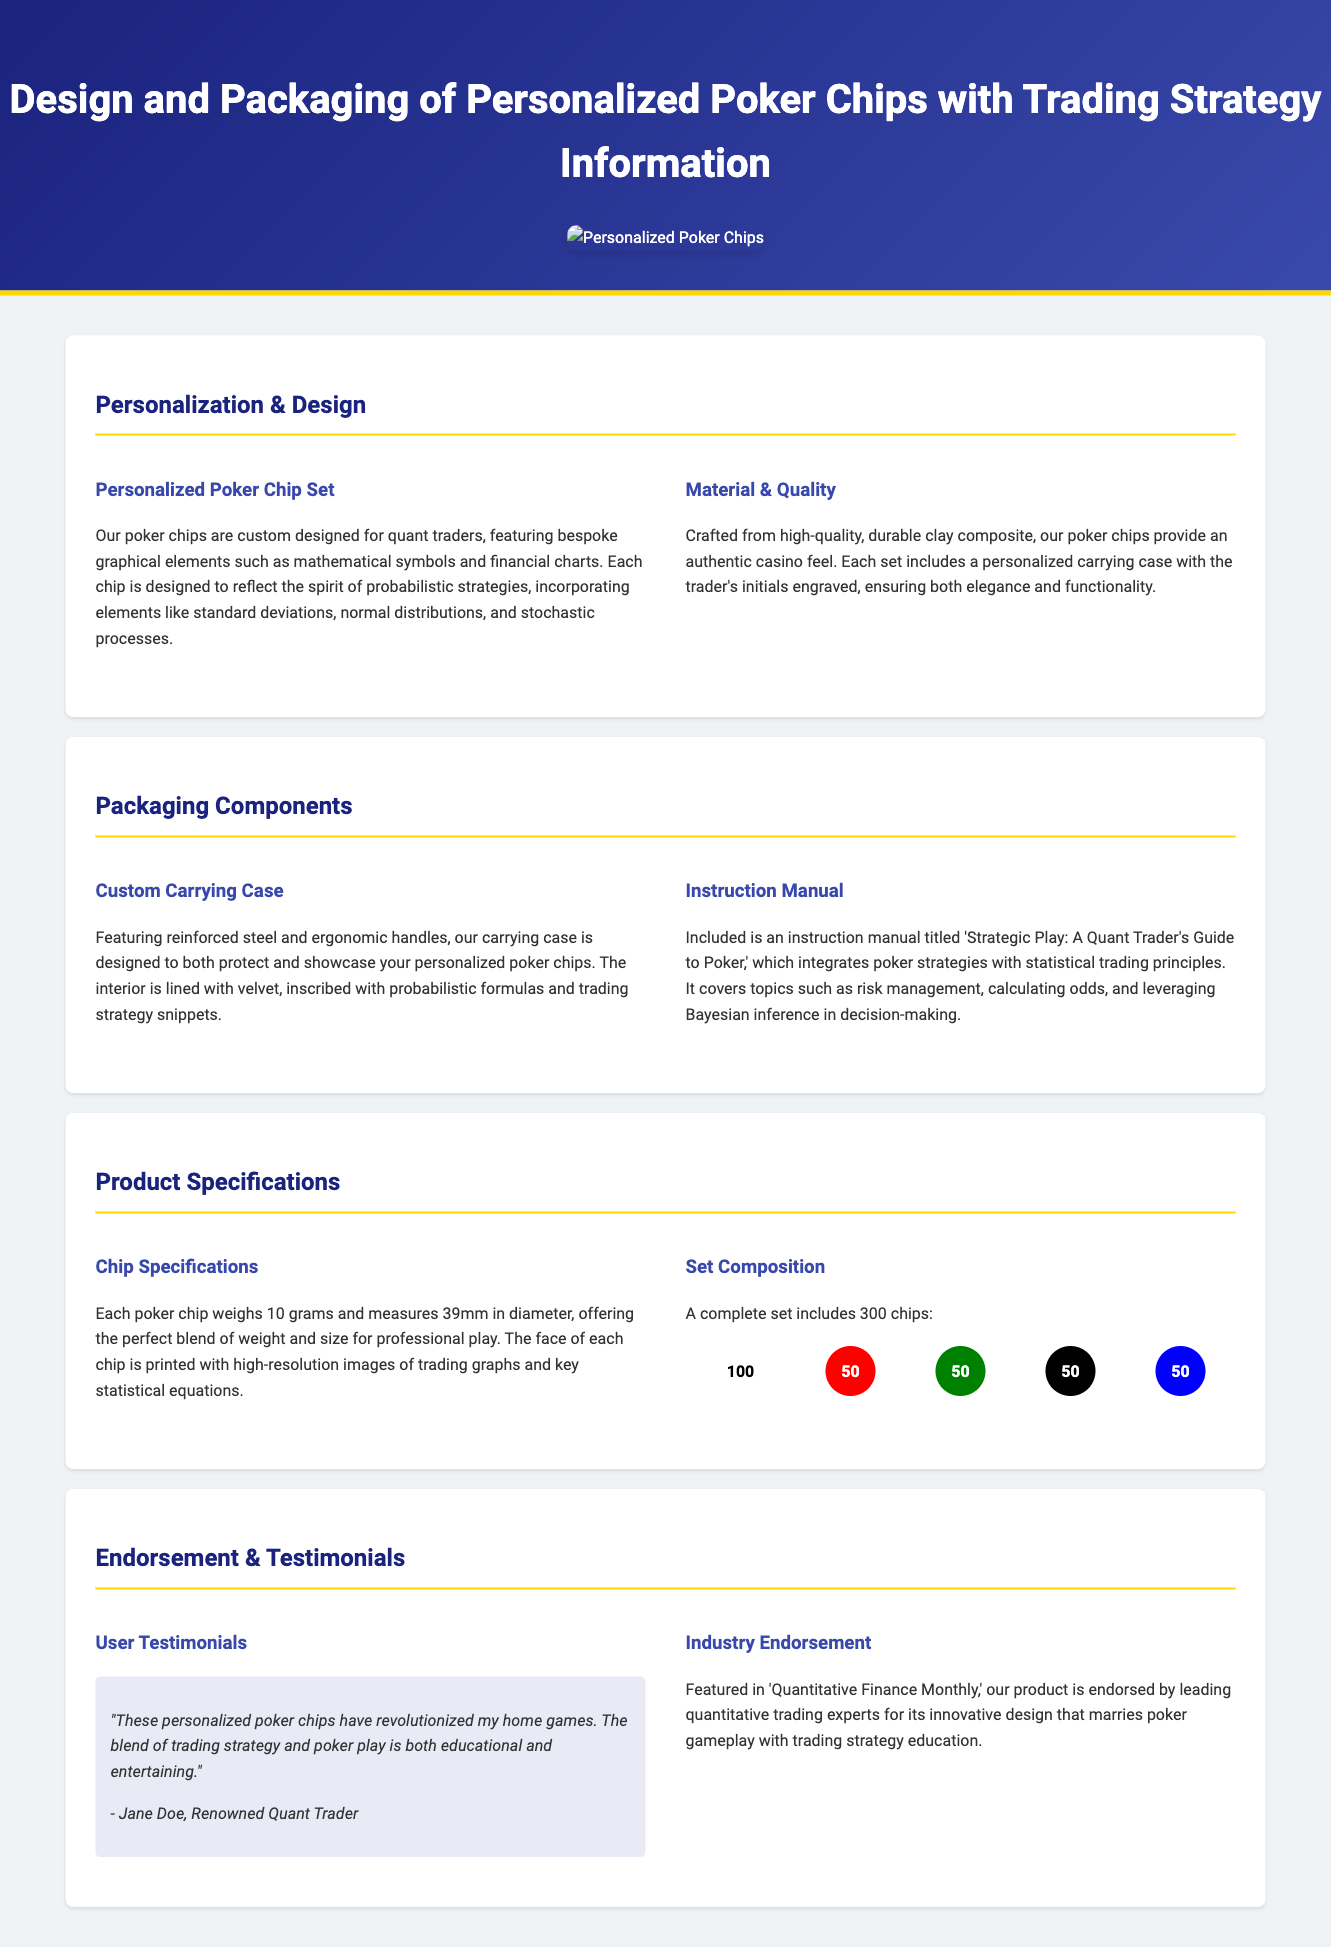what are the bespoke graphical elements featured on the poker chips? The personalized poker chips feature elements such as mathematical symbols and financial charts.
Answer: mathematical symbols and financial charts what is the material of the poker chips? The document states that the poker chips are crafted from high-quality, durable clay composite.
Answer: clay composite how many chips are included in a complete set? The complete set includes a total of 300 chips.
Answer: 300 chips what weight does each poker chip have? Each poker chip weighs 10 grams, as specified in the product specifications section.
Answer: 10 grams who is quoted in the user testimonial? The user testimonial is quoted from Jane Doe, who is a renowned quant trader.
Answer: Jane Doe what topic does the instruction manual cover? The instruction manual titled 'Strategic Play: A Quant Trader's Guide to Poker' covers statistical trading principles integrated with poker strategies.
Answer: statistical trading principles how many of each colored chip are in the complete set? The complete set includes 100 white chips, 50 red chips, 50 green chips, 50 black chips, and 50 blue chips.
Answer: 100 white, 50 red, 50 green, 50 black, 50 blue which publication endorsed the product? The product is endorsed by 'Quantitative Finance Monthly.'
Answer: Quantitative Finance Monthly what is the primary purpose of the custom carrying case? The custom carrying case serves to both protect and showcase the personalized poker chips.
Answer: protect and showcase 